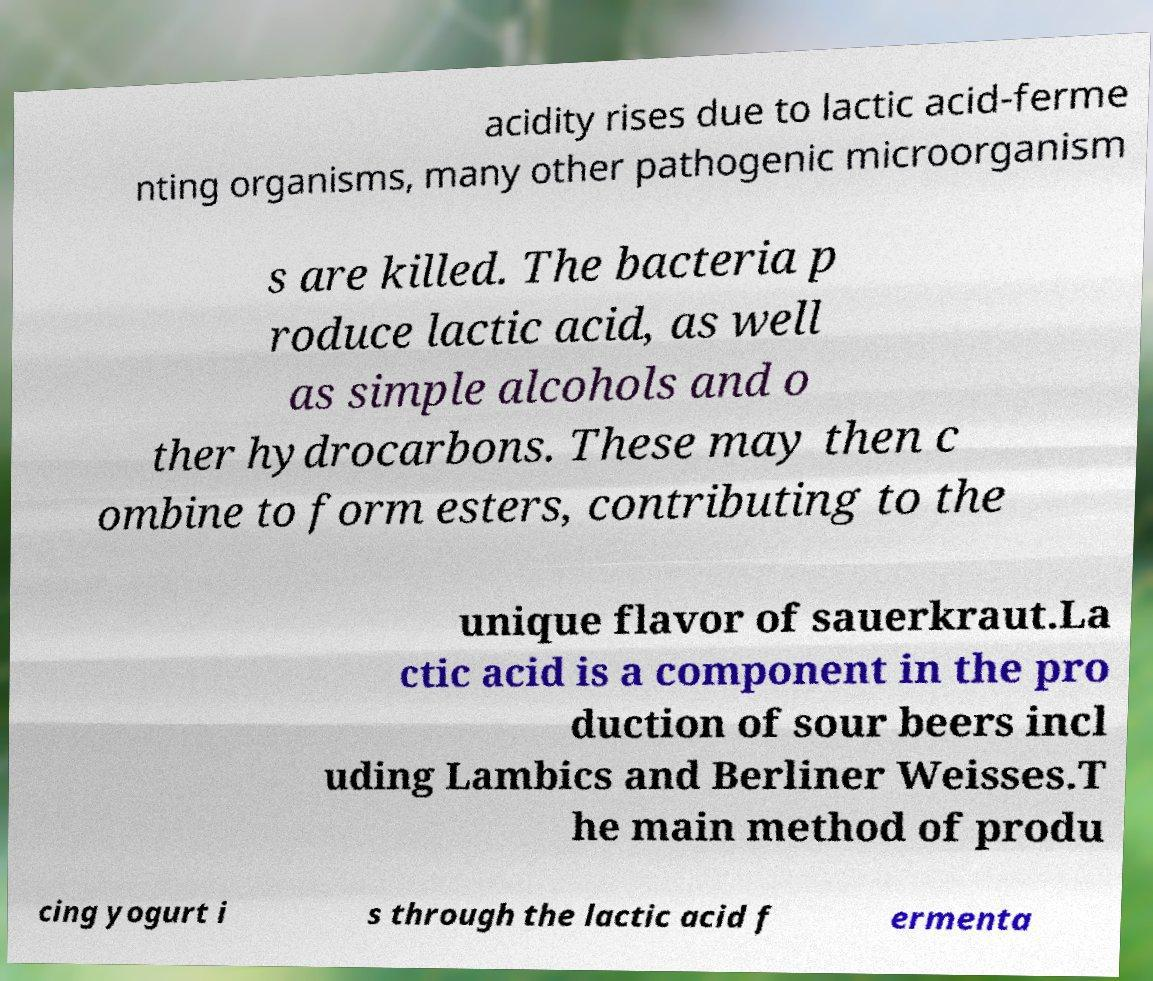Could you assist in decoding the text presented in this image and type it out clearly? acidity rises due to lactic acid-ferme nting organisms, many other pathogenic microorganism s are killed. The bacteria p roduce lactic acid, as well as simple alcohols and o ther hydrocarbons. These may then c ombine to form esters, contributing to the unique flavor of sauerkraut.La ctic acid is a component in the pro duction of sour beers incl uding Lambics and Berliner Weisses.T he main method of produ cing yogurt i s through the lactic acid f ermenta 